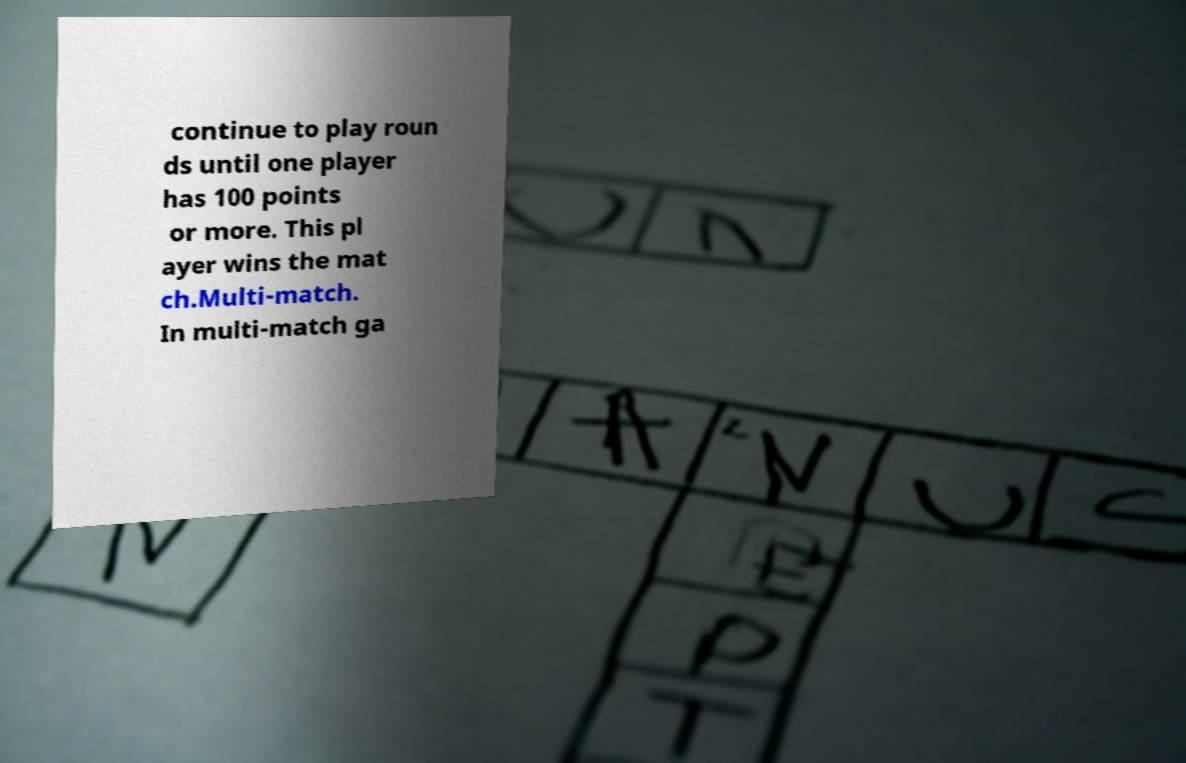Can you read and provide the text displayed in the image?This photo seems to have some interesting text. Can you extract and type it out for me? continue to play roun ds until one player has 100 points or more. This pl ayer wins the mat ch.Multi-match. In multi-match ga 